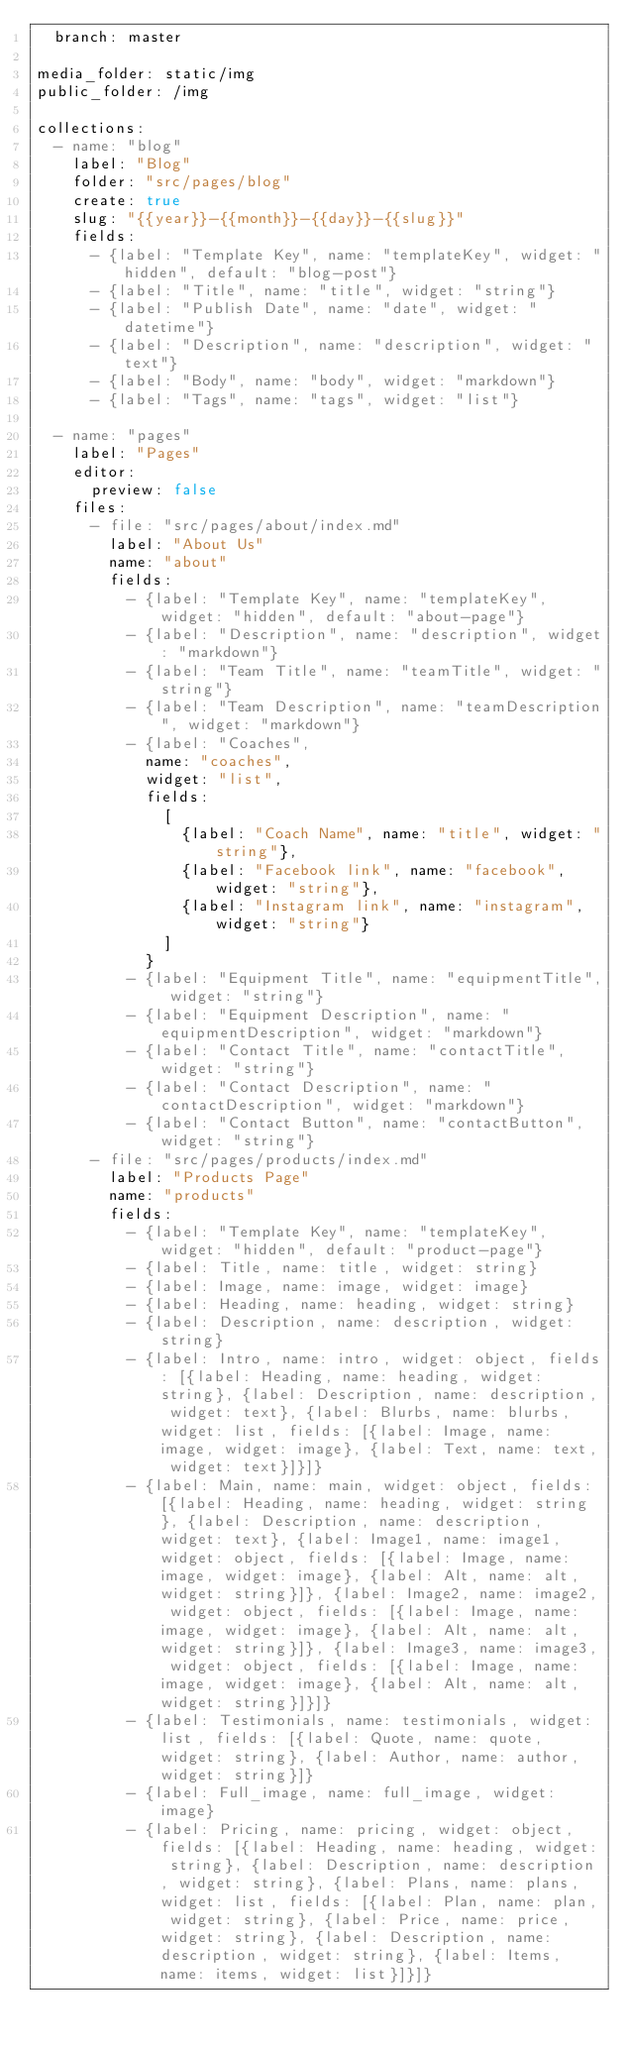<code> <loc_0><loc_0><loc_500><loc_500><_YAML_>  branch: master

media_folder: static/img
public_folder: /img

collections:
  - name: "blog"
    label: "Blog"
    folder: "src/pages/blog"
    create: true
    slug: "{{year}}-{{month}}-{{day}}-{{slug}}"
    fields:
      - {label: "Template Key", name: "templateKey", widget: "hidden", default: "blog-post"}
      - {label: "Title", name: "title", widget: "string"}
      - {label: "Publish Date", name: "date", widget: "datetime"}
      - {label: "Description", name: "description", widget: "text"}
      - {label: "Body", name: "body", widget: "markdown"}
      - {label: "Tags", name: "tags", widget: "list"}

  - name: "pages"
    label: "Pages"
    editor:
      preview: false
    files:
      - file: "src/pages/about/index.md"
        label: "About Us"
        name: "about"
        fields:
          - {label: "Template Key", name: "templateKey", widget: "hidden", default: "about-page"}
          - {label: "Description", name: "description", widget: "markdown"}
          - {label: "Team Title", name: "teamTitle", widget: "string"}
          - {label: "Team Description", name: "teamDescription", widget: "markdown"}
          - {label: "Coaches",
            name: "coaches",
            widget: "list",
            fields:
              [
                {label: "Coach Name", name: "title", widget: "string"},
                {label: "Facebook link", name: "facebook", widget: "string"},
                {label: "Instagram link", name: "instagram", widget: "string"}
              ]
            }
          - {label: "Equipment Title", name: "equipmentTitle", widget: "string"}
          - {label: "Equipment Description", name: "equipmentDescription", widget: "markdown"}
          - {label: "Contact Title", name: "contactTitle", widget: "string"}
          - {label: "Contact Description", name: "contactDescription", widget: "markdown"}
          - {label: "Contact Button", name: "contactButton", widget: "string"}
      - file: "src/pages/products/index.md"
        label: "Products Page"
        name: "products"
        fields:
          - {label: "Template Key", name: "templateKey", widget: "hidden", default: "product-page"}
          - {label: Title, name: title, widget: string}
          - {label: Image, name: image, widget: image}
          - {label: Heading, name: heading, widget: string}
          - {label: Description, name: description, widget: string}
          - {label: Intro, name: intro, widget: object, fields: [{label: Heading, name: heading, widget: string}, {label: Description, name: description, widget: text}, {label: Blurbs, name: blurbs, widget: list, fields: [{label: Image, name: image, widget: image}, {label: Text, name: text, widget: text}]}]}
          - {label: Main, name: main, widget: object, fields: [{label: Heading, name: heading, widget: string}, {label: Description, name: description, widget: text}, {label: Image1, name: image1, widget: object, fields: [{label: Image, name: image, widget: image}, {label: Alt, name: alt, widget: string}]}, {label: Image2, name: image2, widget: object, fields: [{label: Image, name: image, widget: image}, {label: Alt, name: alt, widget: string}]}, {label: Image3, name: image3, widget: object, fields: [{label: Image, name: image, widget: image}, {label: Alt, name: alt, widget: string}]}]}
          - {label: Testimonials, name: testimonials, widget: list, fields: [{label: Quote, name: quote, widget: string}, {label: Author, name: author, widget: string}]}
          - {label: Full_image, name: full_image, widget: image}
          - {label: Pricing, name: pricing, widget: object, fields: [{label: Heading, name: heading, widget: string}, {label: Description, name: description, widget: string}, {label: Plans, name: plans, widget: list, fields: [{label: Plan, name: plan, widget: string}, {label: Price, name: price, widget: string}, {label: Description, name: description, widget: string}, {label: Items, name: items, widget: list}]}]}
</code> 